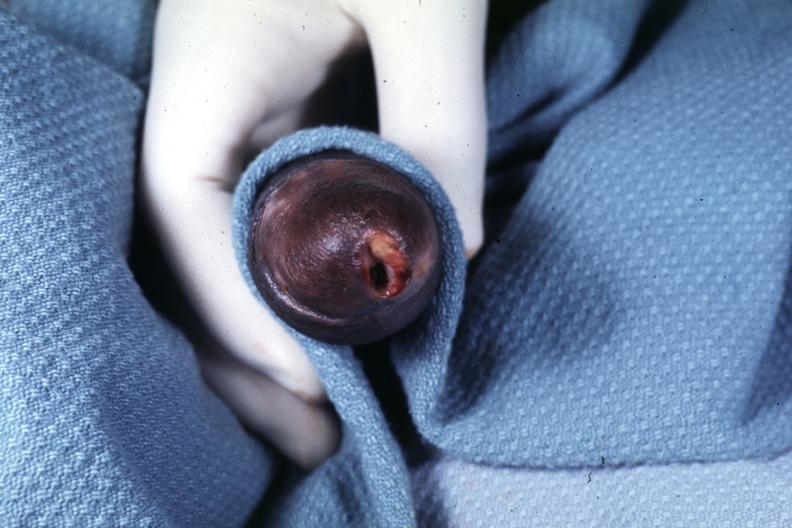what is present?
Answer the question using a single word or phrase. Penis 